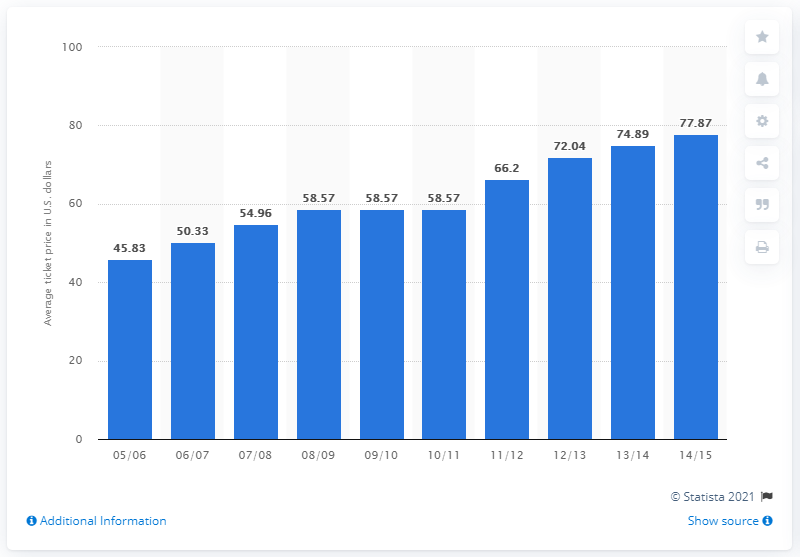Mention a couple of crucial points in this snapshot. According to the 2005/06 season's ticket prices, the average ticket cost 45.83. 